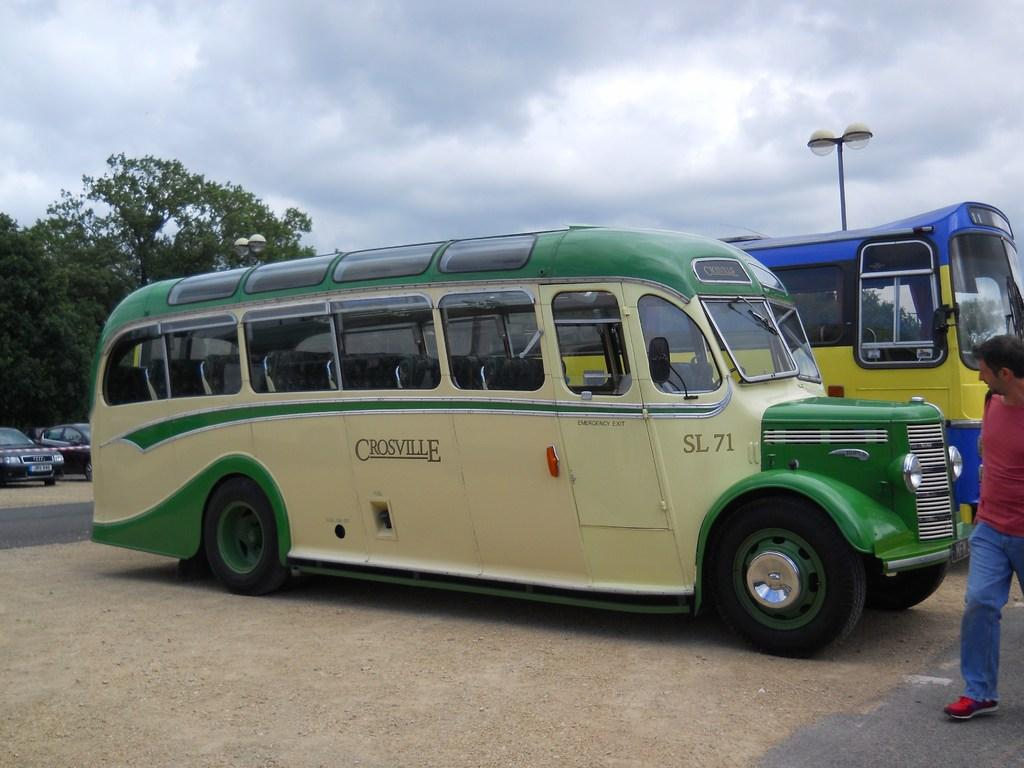What is happening on the road in the image? There are vehicles on the road in the image. What is the person in the image doing? There is a person walking in the image. What can be seen in the background of the image? There are trees and a pole in the background of the image. What is visible above the trees and pole in the image? The sky is visible in the background of the image. What type of rod is being used by the person walking in the image? There is no rod present in the image; the person is simply walking. What surprise can be seen happening in the image? There is no surprise depicted in the image; it shows a person walking and vehicles on the road. 